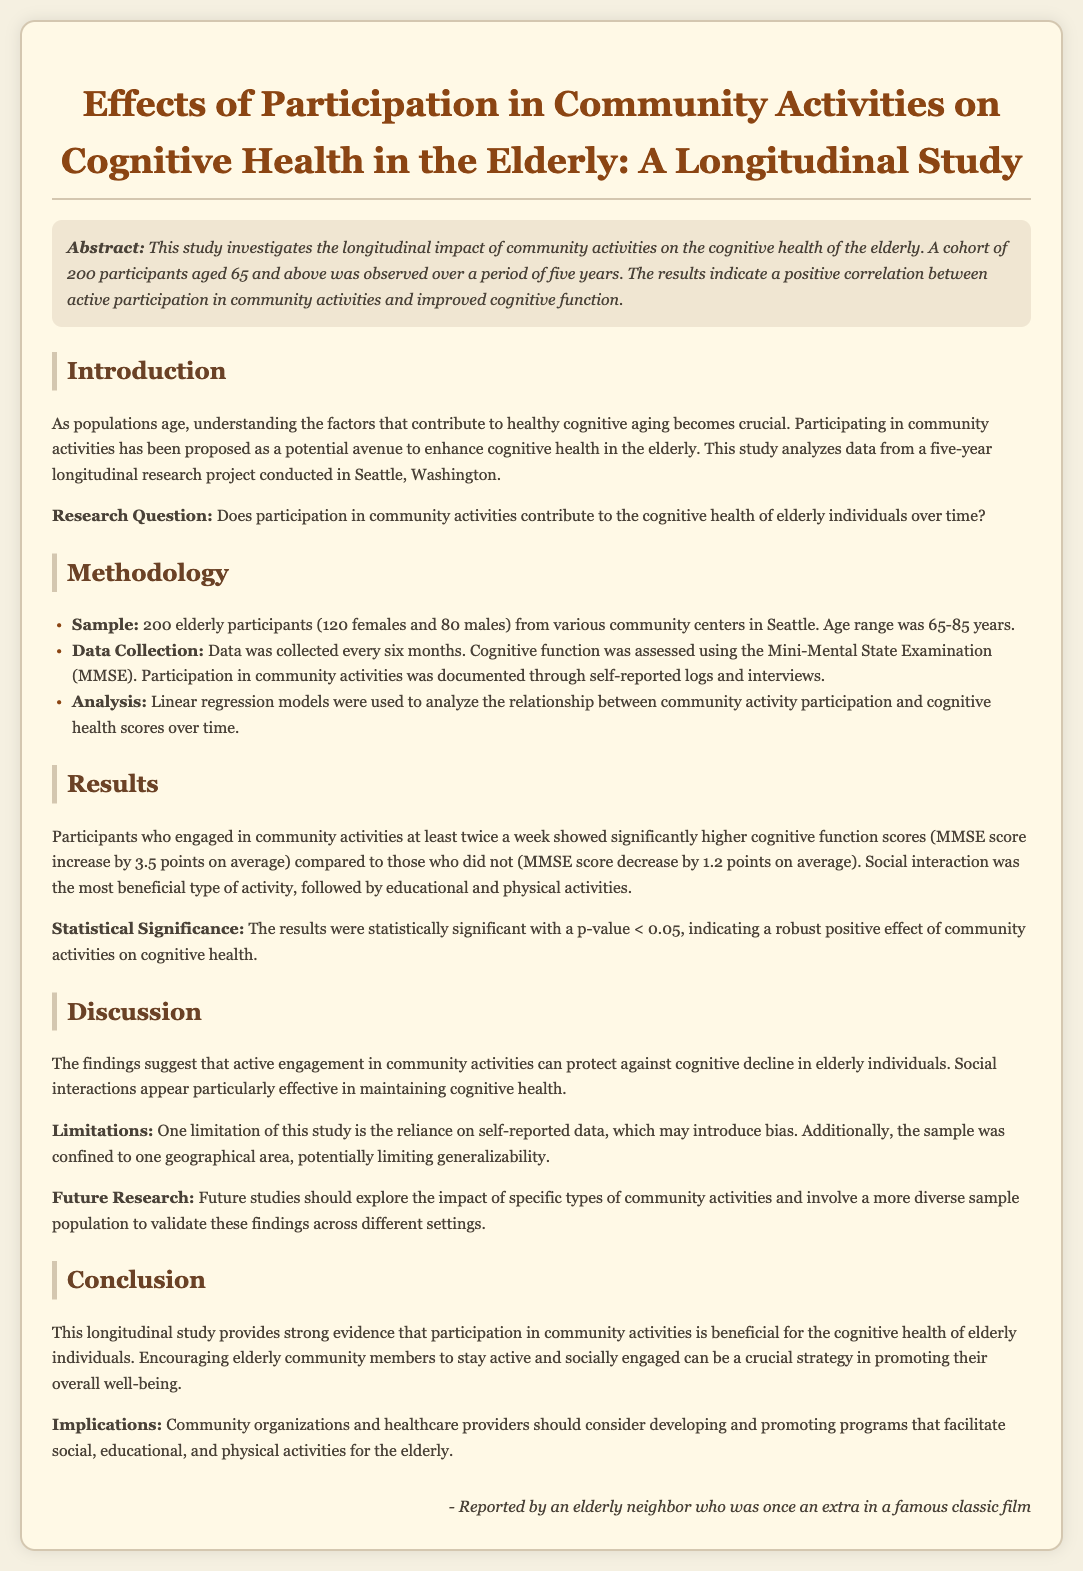what is the sample size of participants? The sample size is given in the methodology section, which states there were 200 participants.
Answer: 200 what measurement tool was used to assess cognitive function? The document mentions the use of the Mini-Mental State Examination (MMSE) for assessing cognitive function.
Answer: Mini-Mental State Examination (MMSE) what was the average MMSE score increase for participants engaged in community activities? The results section provides the average MMSE score increase for those participants, which was 3.5 points.
Answer: 3.5 points what is the age range of participants in the study? The methodology section indicates that the age range of participants was from 65 to 85 years.
Answer: 65-85 years what type of activity was found to be most beneficial for cognitive health? The results mention that social interaction was the most beneficial type of activity for cognitive health.
Answer: Social interaction did the results show a statistically significant effect of community activities on cognitive health? The results state that the p-value was less than 0.05, indicating statistical significance.
Answer: Yes what geographical area was the study conducted in? The introduction section specifies that the study was conducted in Seattle, Washington.
Answer: Seattle, Washington what is one limitation mentioned in the study? The discussion section lists reliance on self-reported data as a limitation of the study.
Answer: Reliance on self-reported data what implication is suggested for community organizations based on the study's findings? The conclusion section recommends that community organizations should develop and promote programs for elderly activities.
Answer: Develop and promote programs 